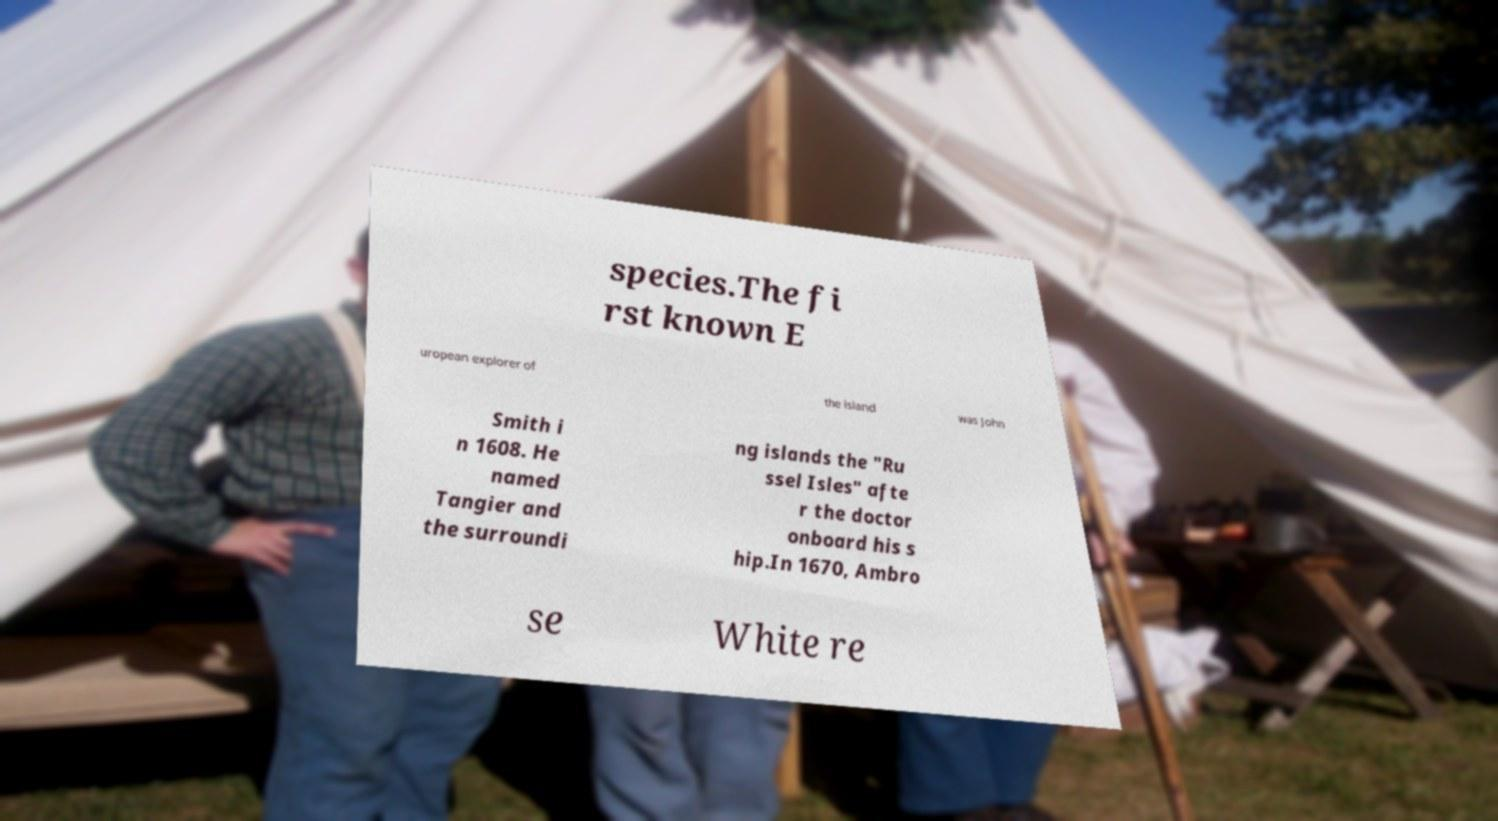Could you assist in decoding the text presented in this image and type it out clearly? species.The fi rst known E uropean explorer of the island was John Smith i n 1608. He named Tangier and the surroundi ng islands the "Ru ssel Isles" afte r the doctor onboard his s hip.In 1670, Ambro se White re 